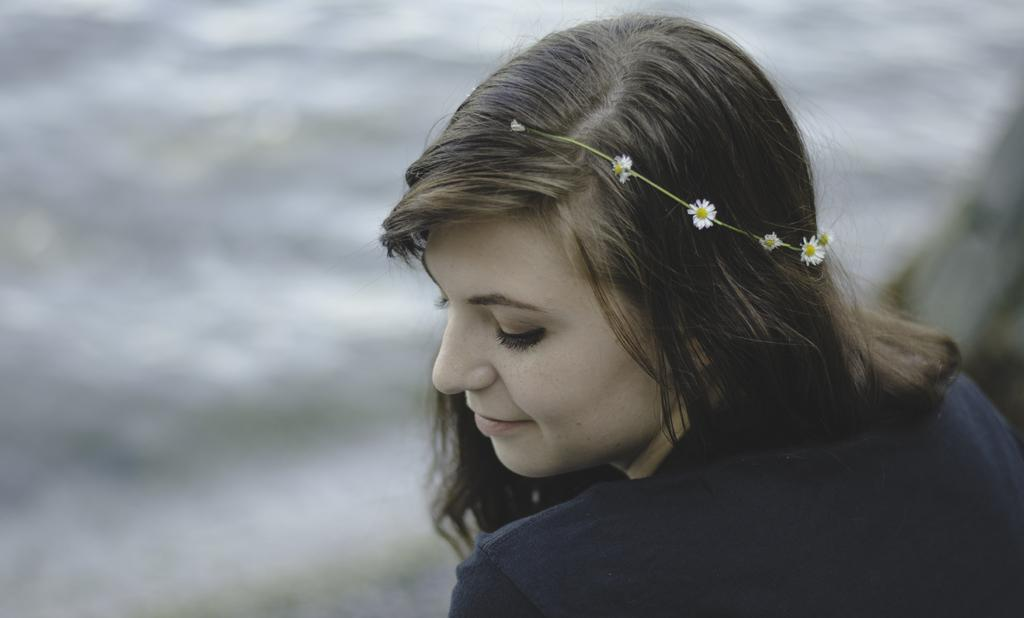Who is the main subject in the image? There is a woman in the image. What is the woman doing in the image? The woman is giving a side pose. What is the woman's facial expression in the image? The woman is slightly smiling. What is the woman wearing in the image? The woman is wearing a blue dress. What is a detail about the woman's appearance in the image? There are flowers in the woman's hair. What type of trucks can be seen in the background of the image? There are no trucks visible in the image; it features a woman in a side pose with flowers in her hair. 